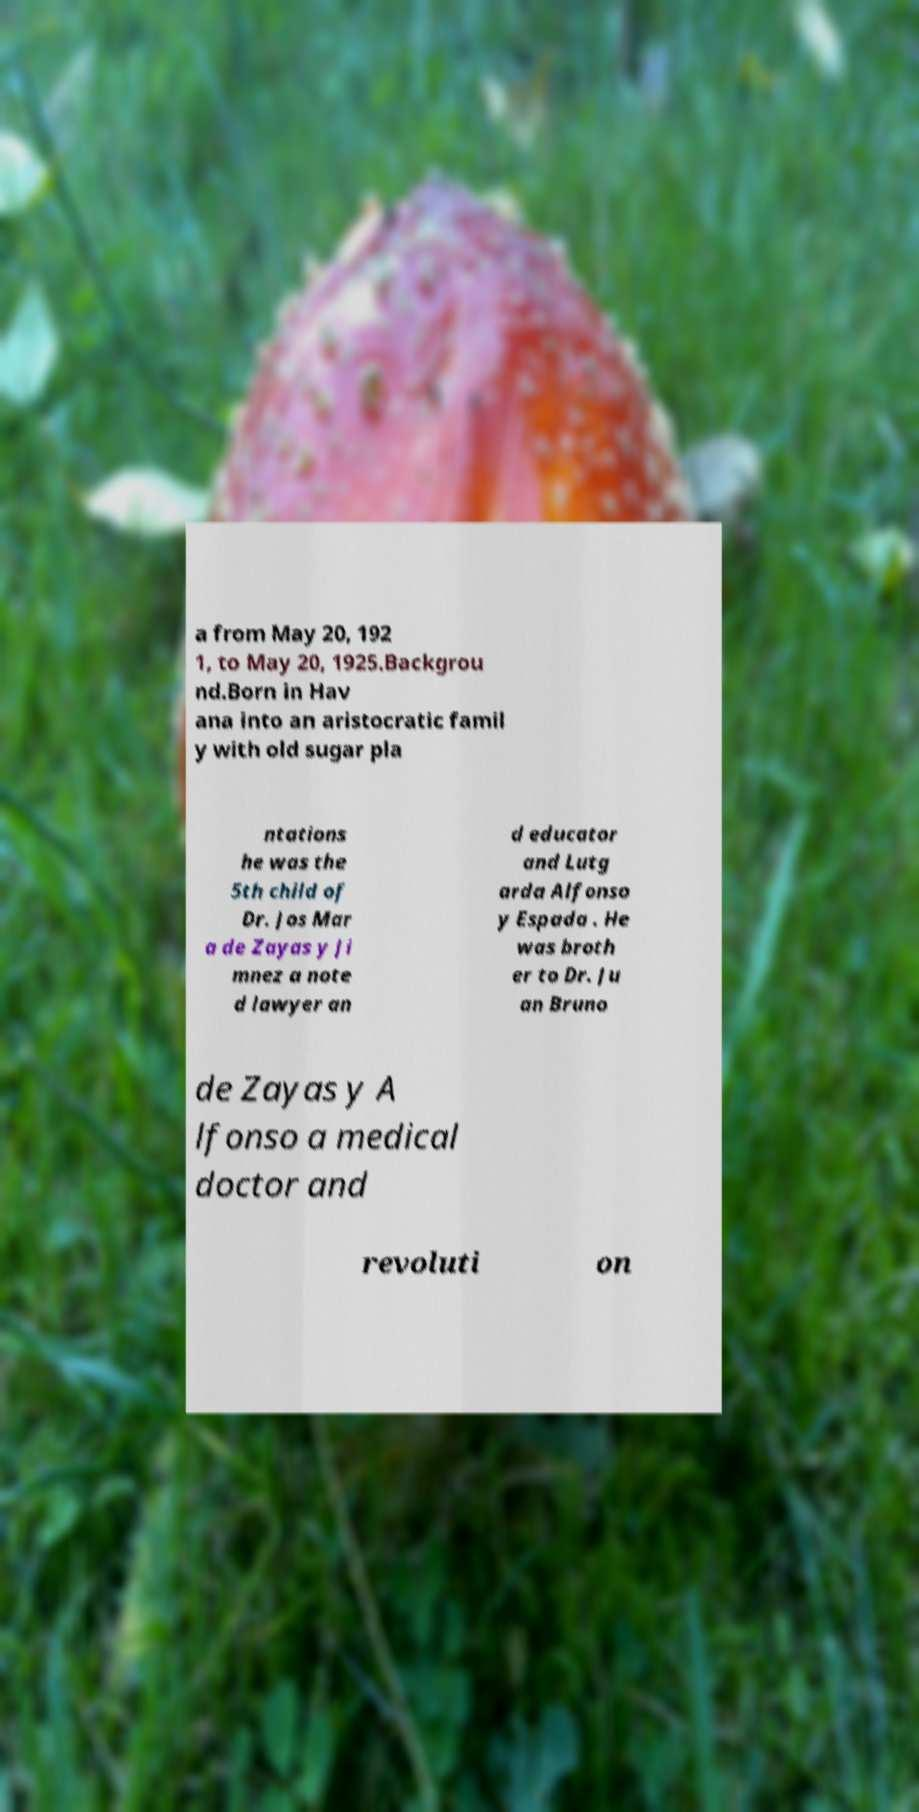Could you assist in decoding the text presented in this image and type it out clearly? a from May 20, 192 1, to May 20, 1925.Backgrou nd.Born in Hav ana into an aristocratic famil y with old sugar pla ntations he was the 5th child of Dr. Jos Mar a de Zayas y Ji mnez a note d lawyer an d educator and Lutg arda Alfonso y Espada . He was broth er to Dr. Ju an Bruno de Zayas y A lfonso a medical doctor and revoluti on 